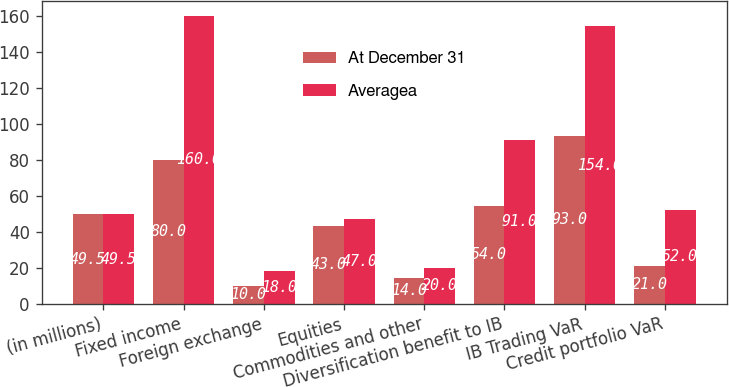Convert chart to OTSL. <chart><loc_0><loc_0><loc_500><loc_500><stacked_bar_chart><ecel><fcel>(in millions)<fcel>Fixed income<fcel>Foreign exchange<fcel>Equities<fcel>Commodities and other<fcel>Diversification benefit to IB<fcel>IB Trading VaR<fcel>Credit portfolio VaR<nl><fcel>At December 31<fcel>49.5<fcel>80<fcel>10<fcel>43<fcel>14<fcel>54<fcel>93<fcel>21<nl><fcel>Averagea<fcel>49.5<fcel>160<fcel>18<fcel>47<fcel>20<fcel>91<fcel>154<fcel>52<nl></chart> 